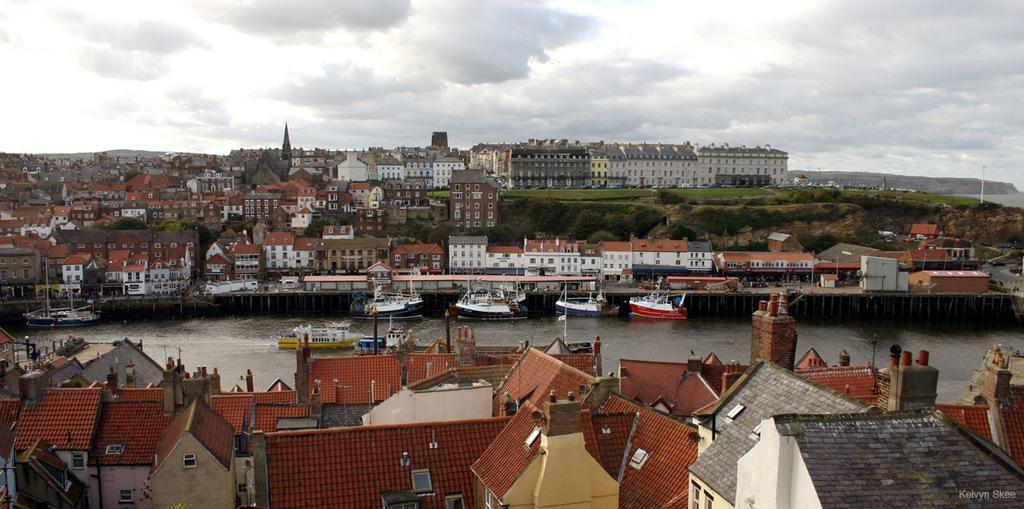Can you describe this image briefly? In this image, we can see some buildings. There are boats floating on water. There are clouds in the sky. 